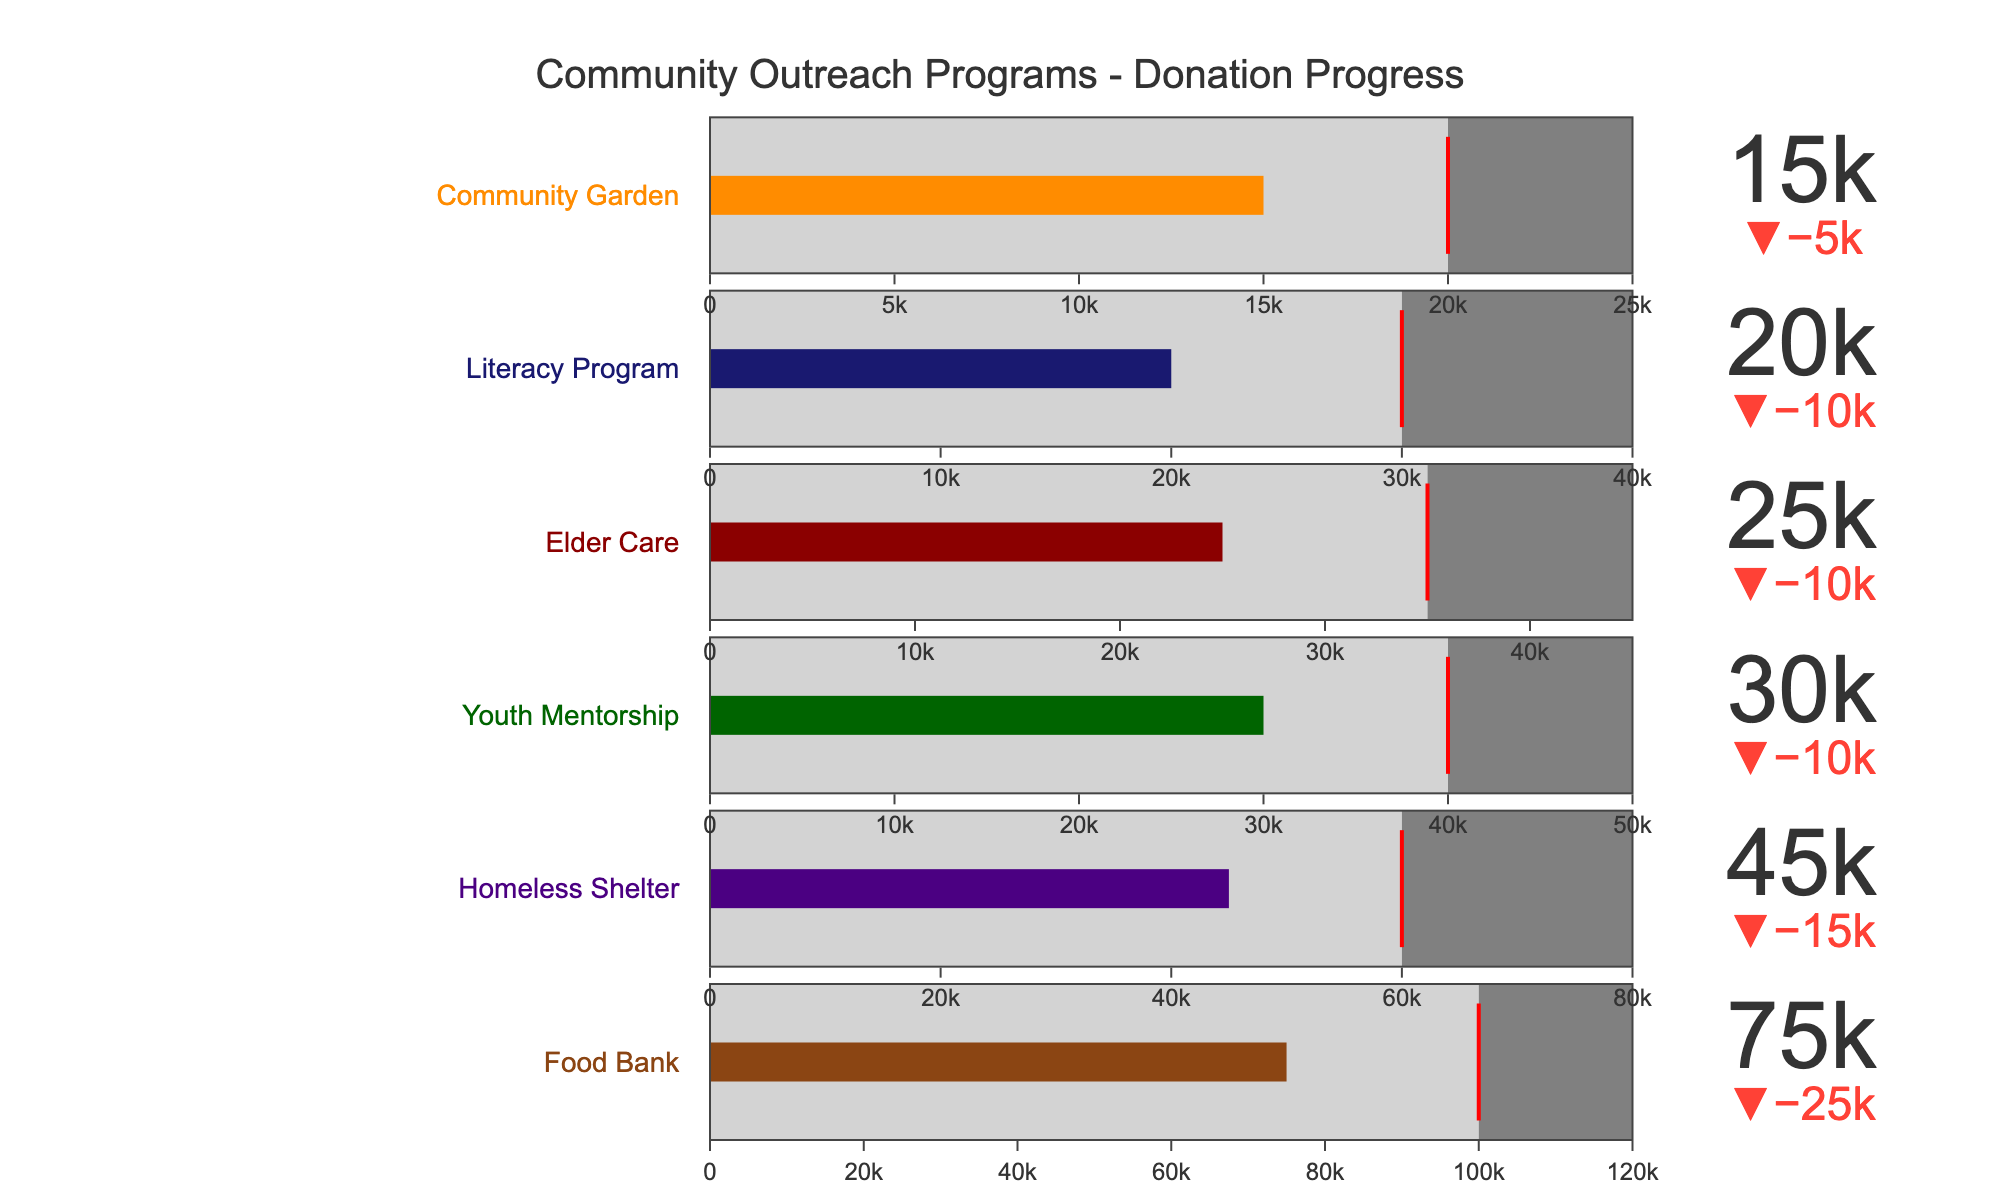What is the title of the figure? The title of the figure is located at the top and clearly indicates the subject matter.
Answer: Community Outreach Programs - Donation Progress How many programs are represented in the figure? By observing the number of bullet charts, we can see the total programs displayed. There are six individual bullet charts in the figure.
Answer: Six Which program has received the highest actual donation? Look for the indicator with the largest number value in the bullet charts.
Answer: Food Bank What is the actual donation amount for the Homeless Shelter program? The actual donation amount is displayed directly within the bullet chart for the Homeless Shelter.
Answer: 45,000 What is the difference between the actual donation and the target for the Youth Mentorship program? Subtract the actual donation from the target for the Youth Mentorship. 40,000 - 30,000 = 10,000
Answer: 10,000 Which program is the closest to reaching its target donation? Compare the actual donation against the target for each program and find the smallest difference.
Answer: Youth Mentorship Which program’s target donation is the highest? Check the target values set for each program and see which one is the largest.
Answer: Food Bank What is the combined target donation of the Elder Care and Literacy Program? Add the target donation amounts for both programs: 35,000 (Elder Care) + 30,000 (Literacy Program) = 65,000
Answer: 65,000 Compare the actual donation amounts of the Community Garden and Elder Care programs. Which is less? Look at the actual donation amounts for both programs and determine which is lower. 15,000 (Community Garden) < 25,000 (Elder Care)
Answer: Community Garden How much more donation is needed for the Food Bank to reach its target? Subtract the actual donation from the target for the Food Bank: 100,000 (Target) - 75,000 (Actual) = 25,000
Answer: 25,000 